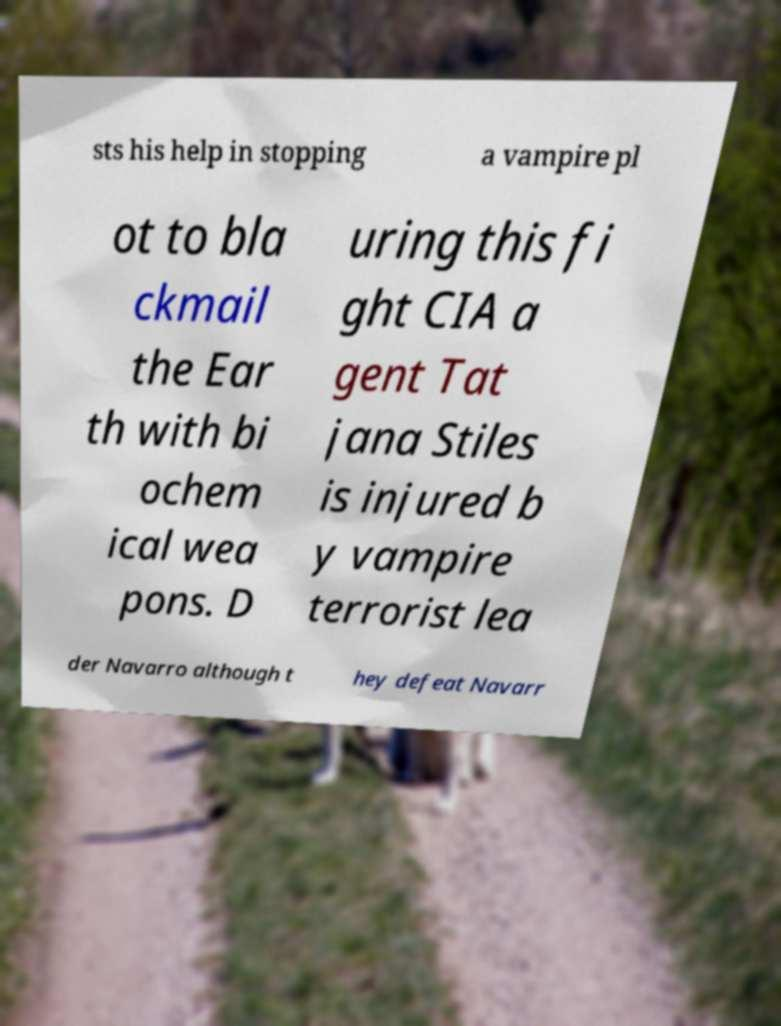I need the written content from this picture converted into text. Can you do that? sts his help in stopping a vampire pl ot to bla ckmail the Ear th with bi ochem ical wea pons. D uring this fi ght CIA a gent Tat jana Stiles is injured b y vampire terrorist lea der Navarro although t hey defeat Navarr 